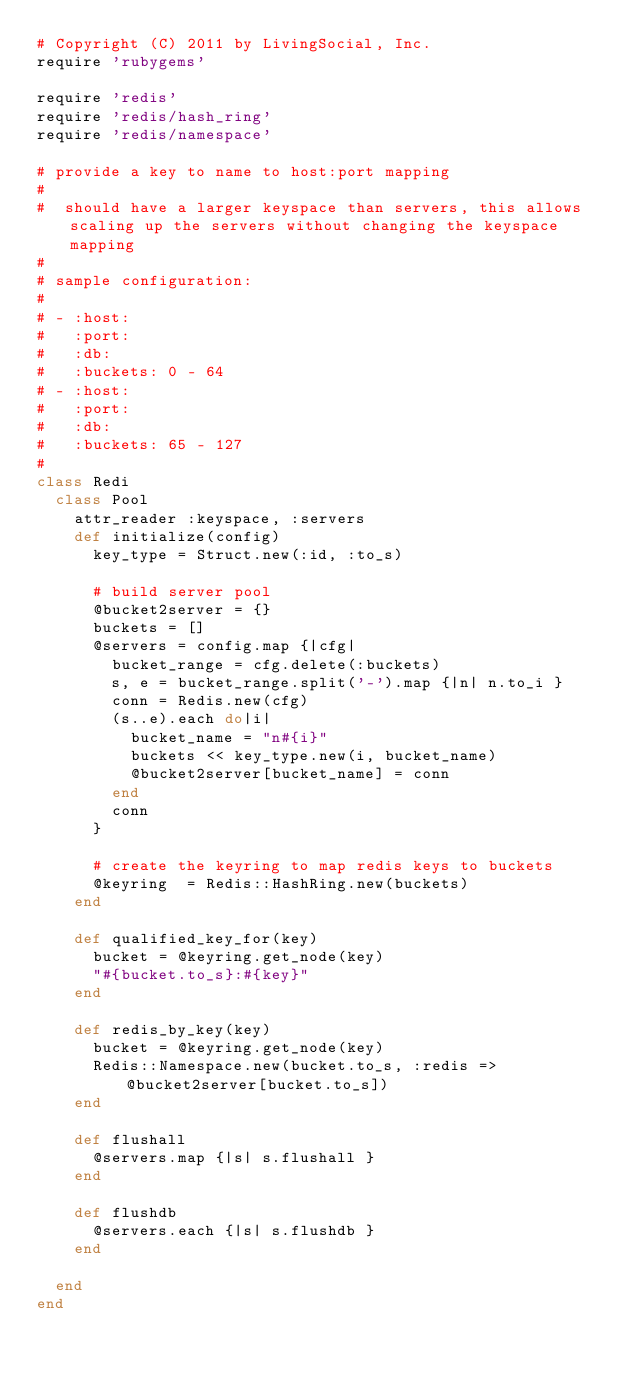<code> <loc_0><loc_0><loc_500><loc_500><_Ruby_># Copyright (C) 2011 by LivingSocial, Inc.
require 'rubygems'

require 'redis'
require 'redis/hash_ring'
require 'redis/namespace'

# provide a key to name to host:port mapping
#
#  should have a larger keyspace than servers, this allows scaling up the servers without changing the keyspace mapping
#
# sample configuration:
#
# - :host:
#   :port:
#   :db:
#   :buckets: 0 - 64
# - :host:
#   :port:
#   :db:
#   :buckets: 65 - 127
#
class Redi
  class Pool
    attr_reader :keyspace, :servers
    def initialize(config)
      key_type = Struct.new(:id, :to_s)

      # build server pool
      @bucket2server = {}
      buckets = []
      @servers = config.map {|cfg|
        bucket_range = cfg.delete(:buckets)
        s, e = bucket_range.split('-').map {|n| n.to_i }
        conn = Redis.new(cfg)
        (s..e).each do|i|
          bucket_name = "n#{i}"
          buckets << key_type.new(i, bucket_name)
          @bucket2server[bucket_name] = conn
        end
        conn
      }

      # create the keyring to map redis keys to buckets
      @keyring  = Redis::HashRing.new(buckets)
    end

    def qualified_key_for(key)
      bucket = @keyring.get_node(key)
      "#{bucket.to_s}:#{key}"
    end

    def redis_by_key(key)
      bucket = @keyring.get_node(key)
      Redis::Namespace.new(bucket.to_s, :redis => @bucket2server[bucket.to_s])
    end

    def flushall
      @servers.map {|s| s.flushall }
    end

    def flushdb
      @servers.each {|s| s.flushdb }
    end

  end
end
</code> 